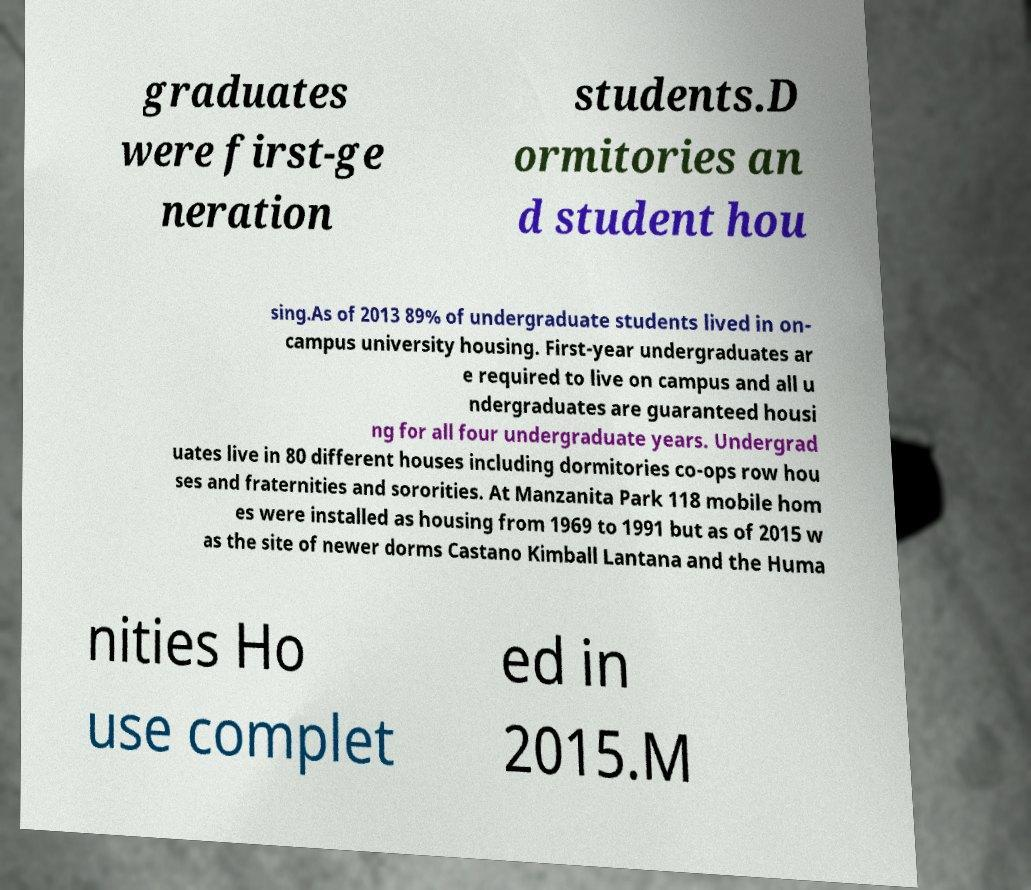There's text embedded in this image that I need extracted. Can you transcribe it verbatim? graduates were first-ge neration students.D ormitories an d student hou sing.As of 2013 89% of undergraduate students lived in on- campus university housing. First-year undergraduates ar e required to live on campus and all u ndergraduates are guaranteed housi ng for all four undergraduate years. Undergrad uates live in 80 different houses including dormitories co-ops row hou ses and fraternities and sororities. At Manzanita Park 118 mobile hom es were installed as housing from 1969 to 1991 but as of 2015 w as the site of newer dorms Castano Kimball Lantana and the Huma nities Ho use complet ed in 2015.M 